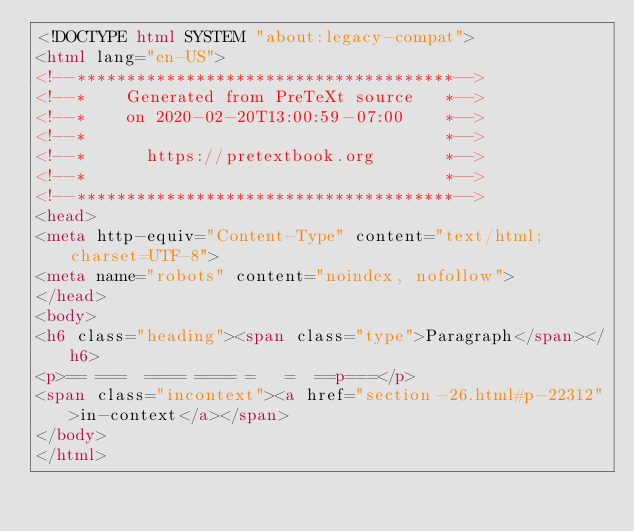<code> <loc_0><loc_0><loc_500><loc_500><_HTML_><!DOCTYPE html SYSTEM "about:legacy-compat">
<html lang="en-US">
<!--**************************************-->
<!--*    Generated from PreTeXt source   *-->
<!--*    on 2020-02-20T13:00:59-07:00    *-->
<!--*                                    *-->
<!--*      https://pretextbook.org       *-->
<!--*                                    *-->
<!--**************************************-->
<head>
<meta http-equiv="Content-Type" content="text/html; charset=UTF-8">
<meta name="robots" content="noindex, nofollow">
</head>
<body>
<h6 class="heading"><span class="type">Paragraph</span></h6>
<p>== ===  ==== ==== =   =  ==p===</p>
<span class="incontext"><a href="section-26.html#p-22312">in-context</a></span>
</body>
</html>
</code> 